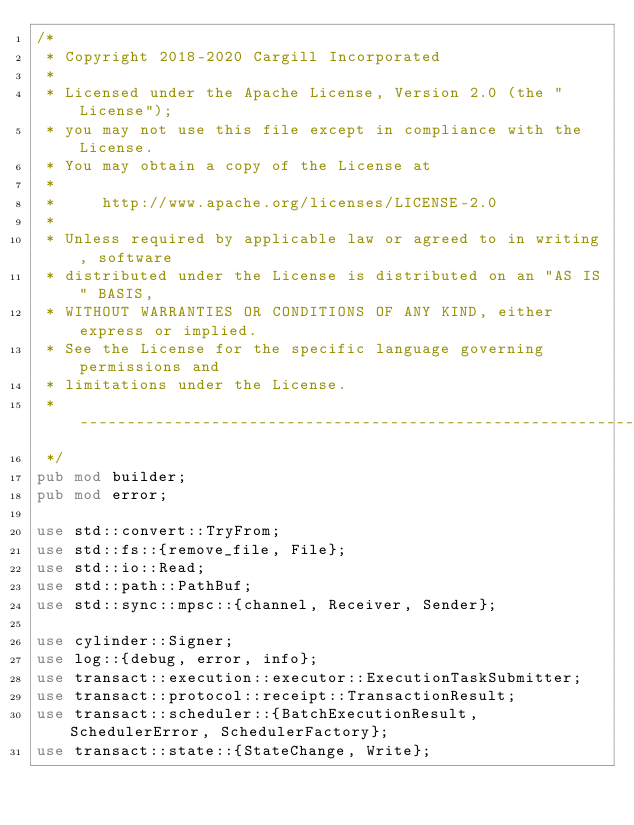Convert code to text. <code><loc_0><loc_0><loc_500><loc_500><_Rust_>/*
 * Copyright 2018-2020 Cargill Incorporated
 *
 * Licensed under the Apache License, Version 2.0 (the "License");
 * you may not use this file except in compliance with the License.
 * You may obtain a copy of the License at
 *
 *     http://www.apache.org/licenses/LICENSE-2.0
 *
 * Unless required by applicable law or agreed to in writing, software
 * distributed under the License is distributed on an "AS IS" BASIS,
 * WITHOUT WARRANTIES OR CONDITIONS OF ANY KIND, either express or implied.
 * See the License for the specific language governing permissions and
 * limitations under the License.
 * ------------------------------------------------------------------------------
 */
pub mod builder;
pub mod error;

use std::convert::TryFrom;
use std::fs::{remove_file, File};
use std::io::Read;
use std::path::PathBuf;
use std::sync::mpsc::{channel, Receiver, Sender};

use cylinder::Signer;
use log::{debug, error, info};
use transact::execution::executor::ExecutionTaskSubmitter;
use transact::protocol::receipt::TransactionResult;
use transact::scheduler::{BatchExecutionResult, SchedulerError, SchedulerFactory};
use transact::state::{StateChange, Write};
</code> 